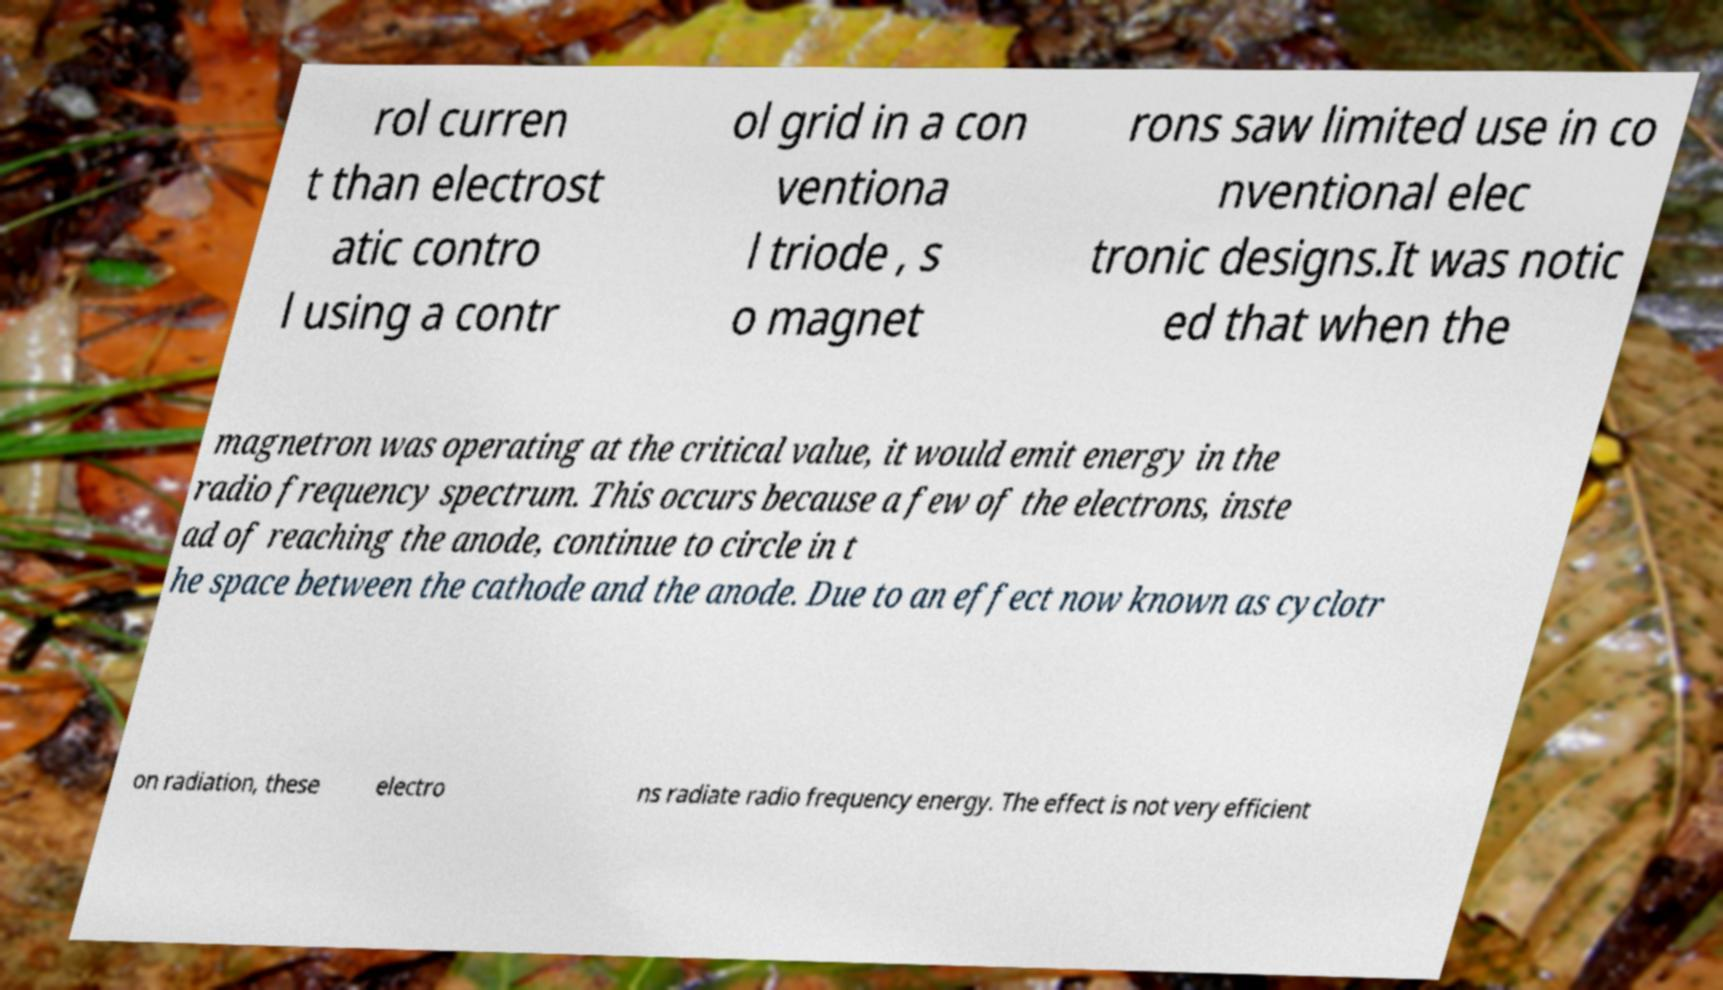Can you accurately transcribe the text from the provided image for me? rol curren t than electrost atic contro l using a contr ol grid in a con ventiona l triode , s o magnet rons saw limited use in co nventional elec tronic designs.It was notic ed that when the magnetron was operating at the critical value, it would emit energy in the radio frequency spectrum. This occurs because a few of the electrons, inste ad of reaching the anode, continue to circle in t he space between the cathode and the anode. Due to an effect now known as cyclotr on radiation, these electro ns radiate radio frequency energy. The effect is not very efficient 